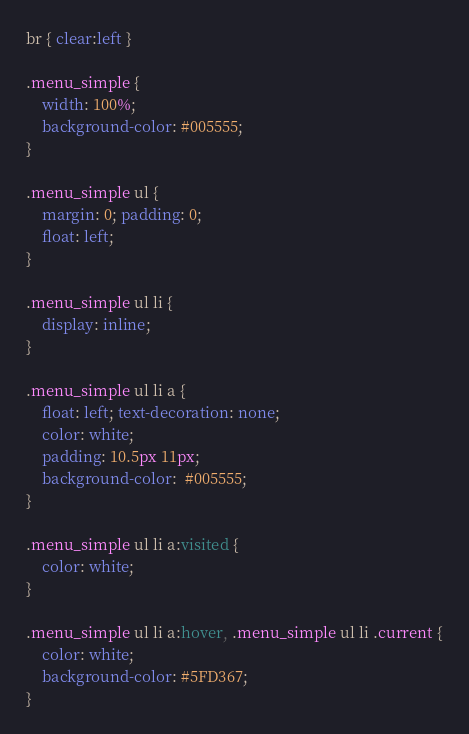<code> <loc_0><loc_0><loc_500><loc_500><_CSS_>
br { clear:left }

.menu_simple {
    width: 100%;
    background-color: #005555;
}

.menu_simple ul {
    margin: 0; padding: 0;
    float: left;
}

.menu_simple ul li {
    display: inline;
}

.menu_simple ul li a {
    float: left; text-decoration: none;
    color: white; 
    padding: 10.5px 11px;
    background-color:  #005555;
}
 
.menu_simple ul li a:visited {
    color: white;
}
 
.menu_simple ul li a:hover, .menu_simple ul li .current {
    color: white;
    background-color: #5FD367;
}</code> 